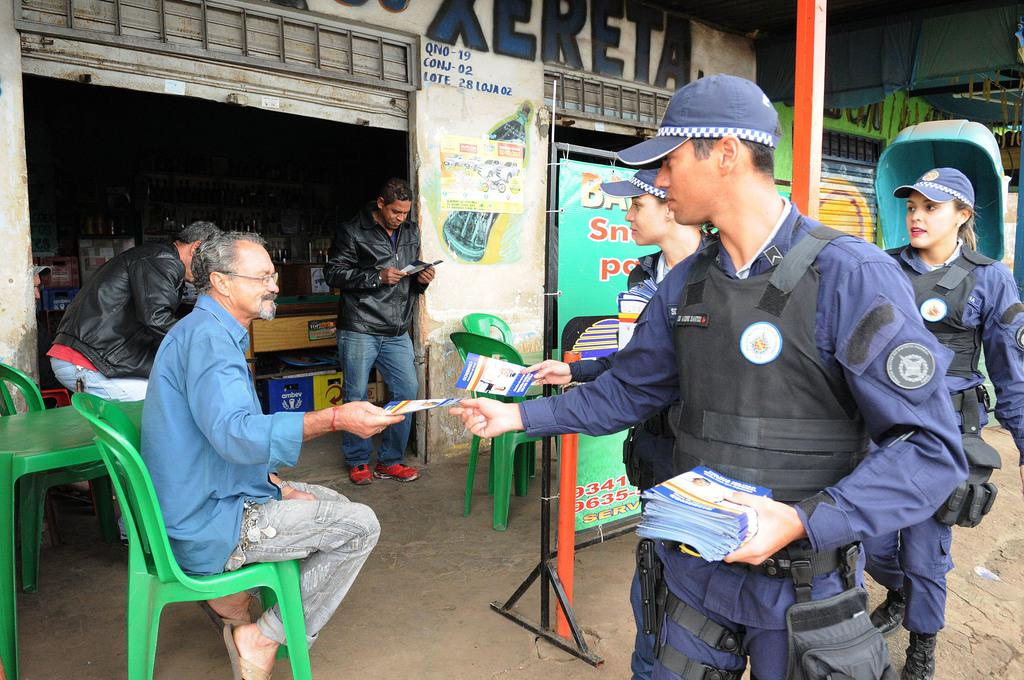What are the people in the image doing? The people in the image are standing and sitting. What type of structure is visible in the image? There is a building in the image. What object can be seen in the image that might contain a liquid? There is a bottle in the image. What type of signage is present in the image? There is a poster in the image. What type of whip can be seen being used by the women in the image? There are no women or whips present in the image. What part of the city is depicted in the image? The image does not specify a location, so it cannot be determined if it is in downtown or any other area. 